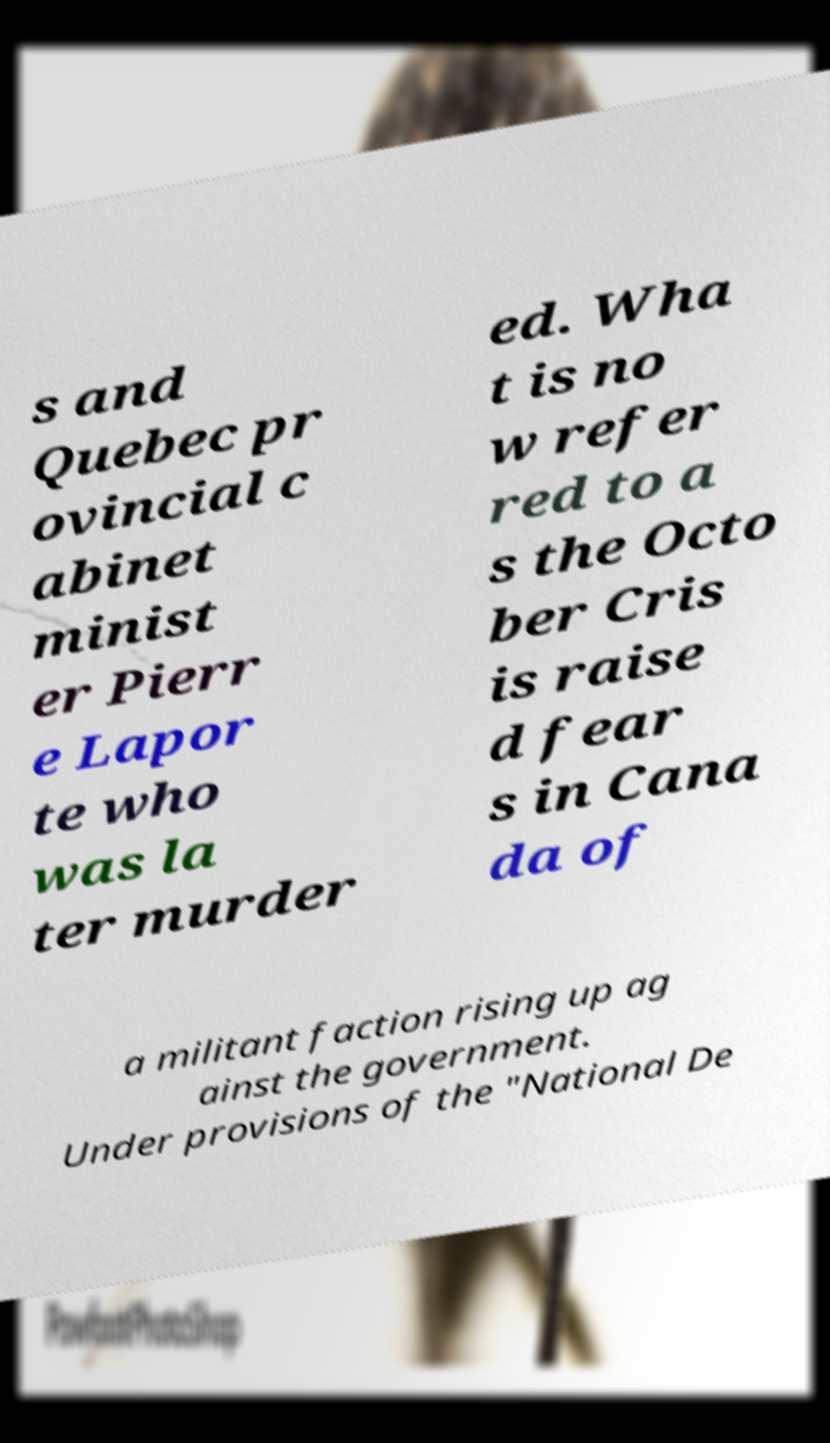Please read and relay the text visible in this image. What does it say? s and Quebec pr ovincial c abinet minist er Pierr e Lapor te who was la ter murder ed. Wha t is no w refer red to a s the Octo ber Cris is raise d fear s in Cana da of a militant faction rising up ag ainst the government. Under provisions of the "National De 